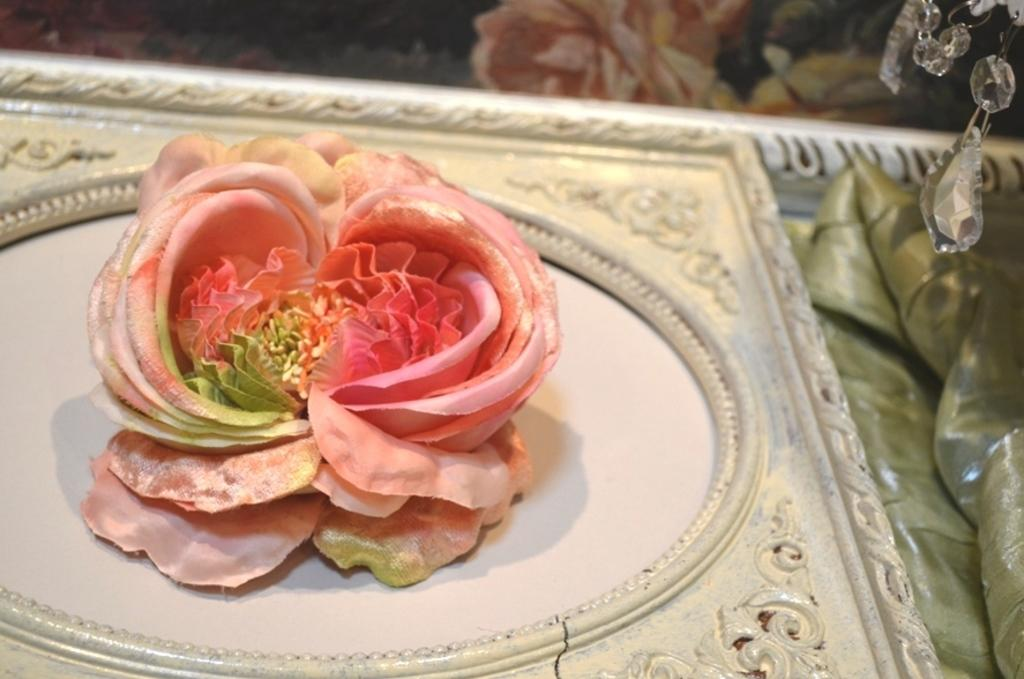What is the main object in the middle of the image? There is a picture frame in the middle of the image. Where is the picture frame located? The picture frame is on a table. What decoration is on the picture frame? There is a rose on the picture frame. What can be seen on the right side of the image? There is a cloth and an object on the right side of the image. Can you describe the girl protesting in the image? There is no girl or protest present in the image; it only features a picture frame, a rose, a table, a cloth, and an object. 